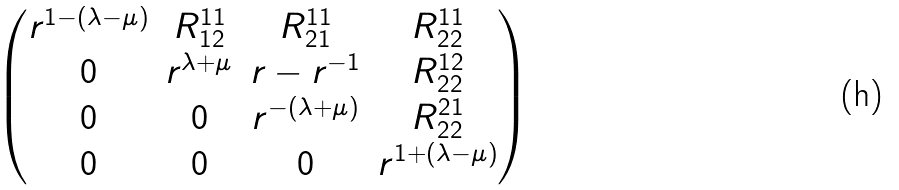Convert formula to latex. <formula><loc_0><loc_0><loc_500><loc_500>\begin{pmatrix} r ^ { 1 - ( \lambda - \mu ) } & R _ { 1 2 } ^ { 1 1 } & R _ { 2 1 } ^ { 1 1 } & R _ { 2 2 } ^ { 1 1 } \\ 0 & r ^ { \lambda + \mu } & r - r ^ { - 1 } & R _ { 2 2 } ^ { 1 2 } \\ 0 & 0 & r ^ { - ( \lambda + \mu ) } & R _ { 2 2 } ^ { 2 1 } \\ 0 & 0 & 0 & r ^ { 1 + ( \lambda - \mu ) } \end{pmatrix}</formula> 